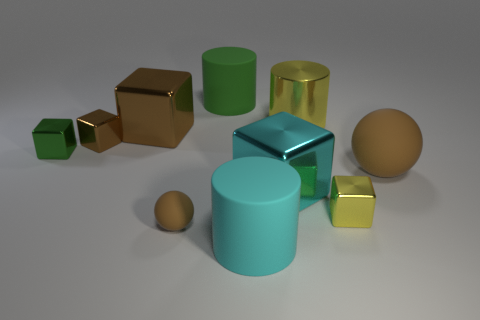There is a large cylinder that is on the left side of the large yellow metallic object and behind the small brown shiny block; what material is it?
Make the answer very short. Rubber. There is a tiny brown thing in front of the large cyan cube; is its shape the same as the brown thing that is right of the big green matte cylinder?
Ensure brevity in your answer.  Yes. There is a small object that is the same color as the tiny matte sphere; what is its shape?
Offer a very short reply. Cube. How many objects are either big blocks that are to the right of the green matte object or large matte objects?
Keep it short and to the point. 4. Is the yellow cylinder the same size as the green cylinder?
Give a very brief answer. Yes. The large metallic block behind the green cube is what color?
Ensure brevity in your answer.  Brown. What size is the cyan object that is the same material as the small brown sphere?
Ensure brevity in your answer.  Large. There is a yellow cylinder; is it the same size as the cylinder that is in front of the cyan metal block?
Offer a terse response. Yes. What is the big cylinder that is in front of the green cube made of?
Offer a very short reply. Rubber. How many yellow metallic objects are left of the large cylinder that is in front of the green cube?
Your answer should be compact. 0. 